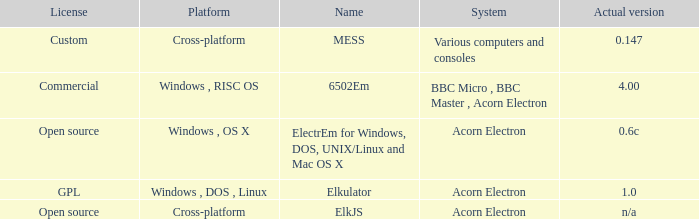What is the name of the platform used for various computers and consoles? Cross-platform. 